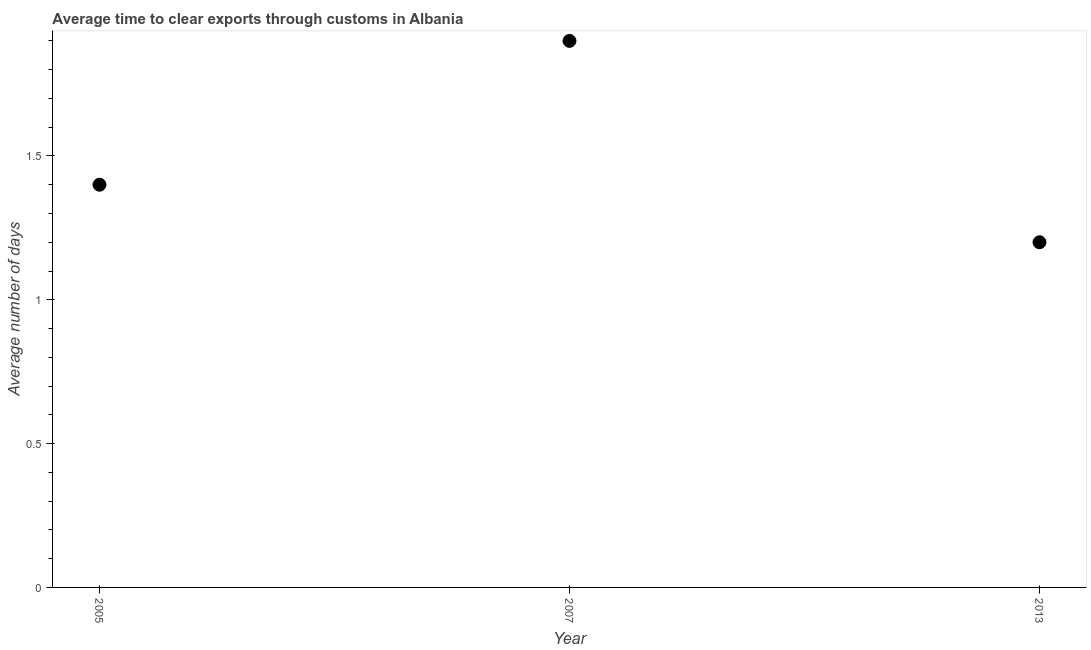What is the time to clear exports through customs in 2013?
Provide a short and direct response. 1.2. In which year was the time to clear exports through customs minimum?
Provide a short and direct response. 2013. What is the sum of the time to clear exports through customs?
Offer a terse response. 4.5. What is the difference between the time to clear exports through customs in 2005 and 2013?
Your answer should be compact. 0.2. What is the average time to clear exports through customs per year?
Ensure brevity in your answer.  1.5. What is the median time to clear exports through customs?
Make the answer very short. 1.4. What is the ratio of the time to clear exports through customs in 2007 to that in 2013?
Offer a terse response. 1.58. Is the time to clear exports through customs in 2007 less than that in 2013?
Keep it short and to the point. No. What is the difference between the highest and the lowest time to clear exports through customs?
Keep it short and to the point. 0.7. In how many years, is the time to clear exports through customs greater than the average time to clear exports through customs taken over all years?
Ensure brevity in your answer.  1. What is the title of the graph?
Keep it short and to the point. Average time to clear exports through customs in Albania. What is the label or title of the X-axis?
Ensure brevity in your answer.  Year. What is the label or title of the Y-axis?
Offer a terse response. Average number of days. What is the Average number of days in 2005?
Provide a succinct answer. 1.4. What is the Average number of days in 2013?
Provide a short and direct response. 1.2. What is the difference between the Average number of days in 2005 and 2013?
Your answer should be very brief. 0.2. What is the ratio of the Average number of days in 2005 to that in 2007?
Provide a succinct answer. 0.74. What is the ratio of the Average number of days in 2005 to that in 2013?
Offer a very short reply. 1.17. What is the ratio of the Average number of days in 2007 to that in 2013?
Your answer should be compact. 1.58. 